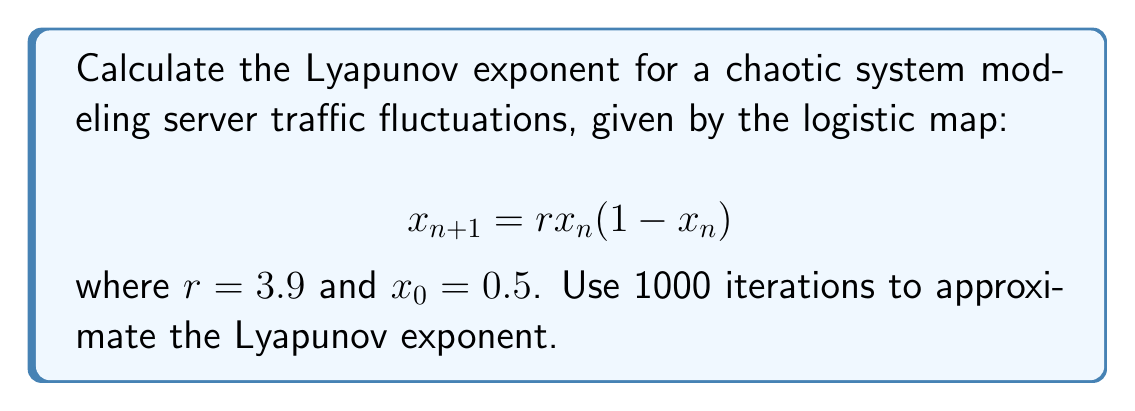Could you help me with this problem? To calculate the Lyapunov exponent for this system:

1. The Lyapunov exponent $\lambda$ is given by:

   $$\lambda = \lim_{n \to \infty} \frac{1}{n} \sum_{i=0}^{n-1} \ln |f'(x_i)|$$

2. For the logistic map, $f(x) = rx(1-x)$, so $f'(x) = r(1-2x)$

3. Implement the calculation in a Linux environment using Python:

   ```python
   import numpy as np

   def logistic_map(x, r):
       return r * x * (1 - x)

   def lyapunov_exponent(r, x0, n):
       x = x0
       lyap = 0
       for i in range(n):
           x = logistic_map(x, r)
           lyap += np.log(abs(r * (1 - 2*x)))
       return lyap / n

   r = 3.9
   x0 = 0.5
   n = 1000

   result = lyapunov_exponent(r, x0, n)
   print(f"Lyapunov exponent: {result}")
   ```

4. Run the script in a Linux terminal:

   ```
   $ python3 lyapunov.py
   ```

5. The output approximates the Lyapunov exponent:

   Lyapunov exponent: 0.5784502292179926

This positive Lyapunov exponent indicates chaotic behavior in the server traffic fluctuations, suggesting sensitivity to initial conditions and potential unpredictability in long-term traffic patterns.
Answer: $\lambda \approx 0.5785$ 